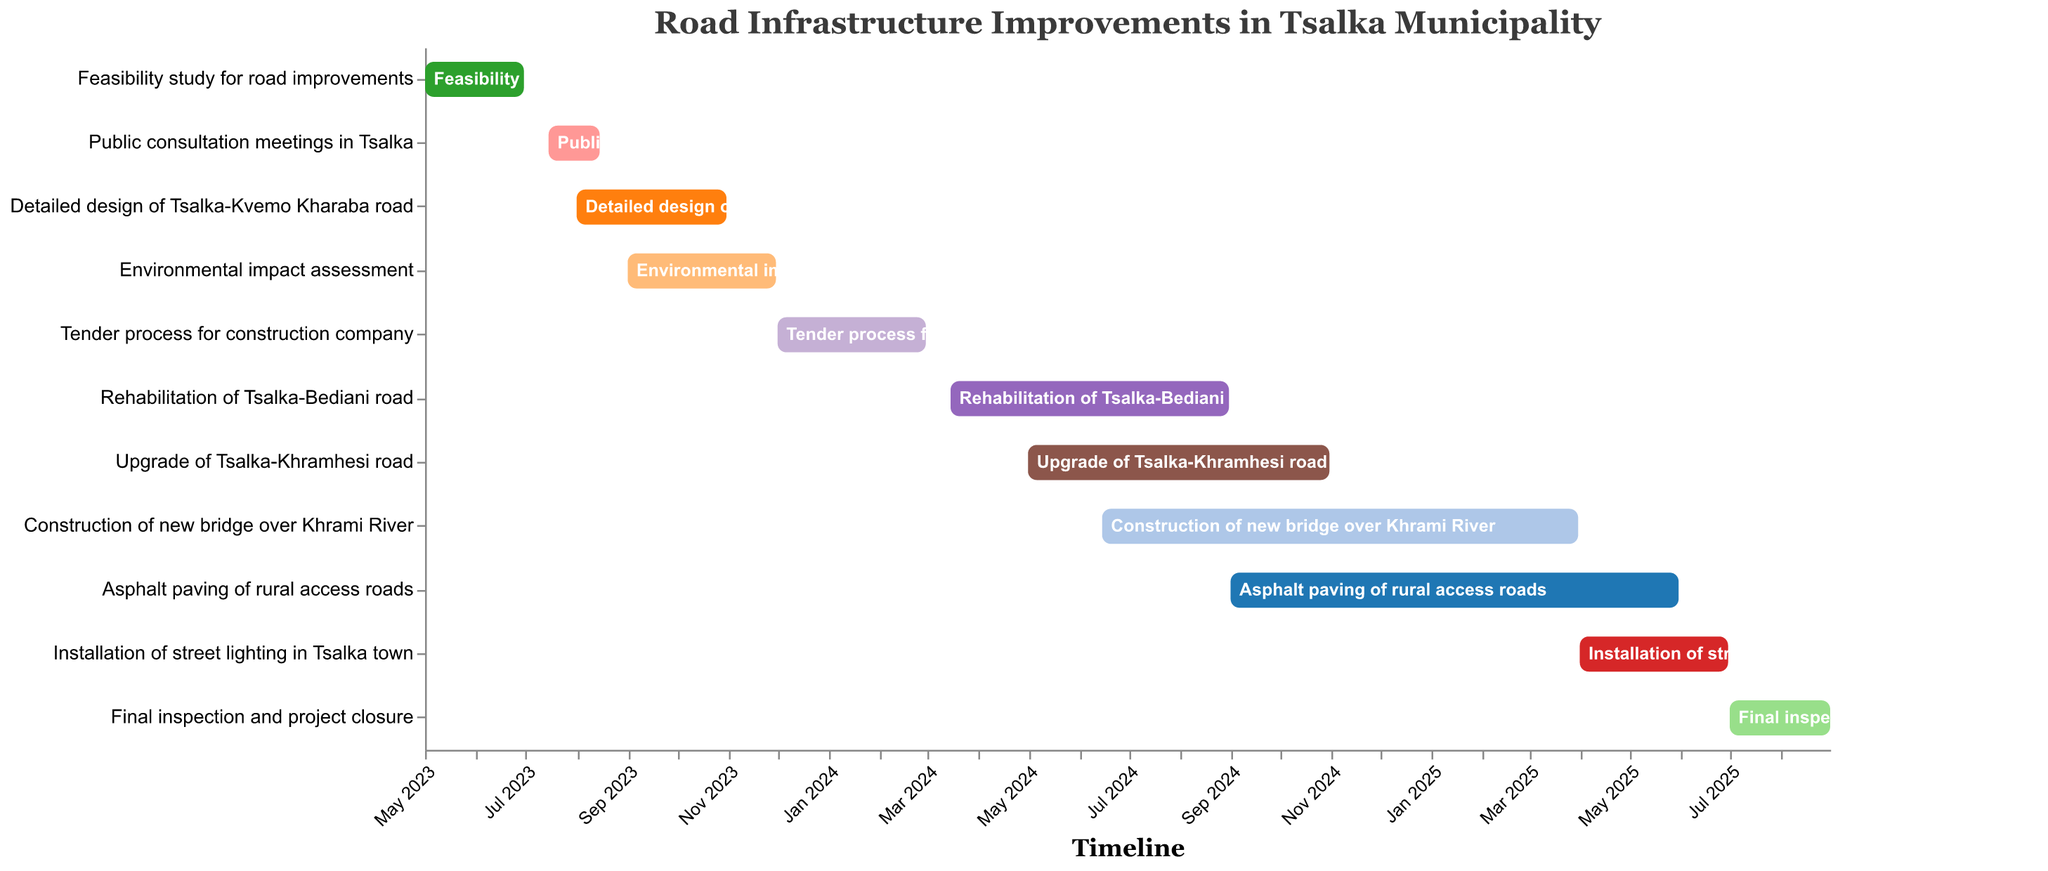When will the feasibility study for road improvements start? The feasibility study for road improvements starts at the "Start Date" of the first task listed in the figure.
Answer: May 1, 2023 How long is the duration of the public consultation meetings in Tsalka? The duration is calculated by finding the difference between the "End Date" and the "Start Date" of the public consultation meetings' task. The task starts on July 15, 2023, and ends on August 15, 2023.
Answer: 1 month Which task has the longest duration? The longest duration is found by comparing the length of time from the start to end date for each task. The "Construction of new bridge over Khrami River" starts on June 15, 2024, and ends on March 31, 2025, which spans over 9.5 months.
Answer: Construction of new bridge over Khrami River When will the final inspection and project closure take place? The "Start Date" and "End Date" for the final inspection and project closure are directly provided in the figure. The task starts on July 1, 2025, and ends on August 31, 2025.
Answer: July 1, 2025 to August 31, 2025 How many tasks will be occurring simultaneously in September 2024? Identify tasks that are ongoing in September 2024. These tasks include "Rehabilitation of Tsalka-Bediani road" (until August 31, 2024), "Upgrade of Tsalka-Khramhesi road" (until October 31, 2024), "Construction of new bridge over Khrami River" (until March 31, 2025), and "Asphalt paving of rural access roads" (starting September 1, 2024).
Answer: 4 tasks Which tasks overlap with the environmental impact assessment? To find overlapping tasks, compare the timeline of the "Environmental impact assessment" (September 1, 2023, to November 30, 2023) with other tasks. The overlapping tasks are "Detailed design of Tsalka-Kvemo Kharaba road" (until October 31, 2023) and "Tender process for construction company" (starting December 1, 2023).
Answer: Detailed design of Tsalka-Kvemo Kharaba road What is the total time span covered by the entire project timeline? The total span is calculated by identifying the "Start Date" of the first task and the "End Date" of the last task. The project starts on May 1, 2023, and ends on August 31, 2025.
Answer: 28 months When does the installation of street lighting in Tsalka town start? The start date of the installation of street lighting in Tsalka town is directly provided in the figure.
Answer: April 1, 2025 What is the sequence of tasks starting from the detailed design of Tsalka-Kvemo Kharaba road? To determine the sequence, list the tasks starting after the detailed design of Tsalka-Kvemo Kharaba road (August 1, 2023, to October 31, 2023). Next tasks are "Environmental impact assessment," followed by "Tender process for construction company," and so on.
Answer: Environmental impact assessment, Tender process for construction company, Rehabilitation of Tsalka-Bediani road, Upgrade of Tsalka-Khramhesi road, Construction of new bridge over Khrami River, Asphalt paving of rural access roads, Installation of street lighting in Tsalka town, Final inspection and project closure When is the asphalt paving of rural access roads scheduled to end? The end date for asphalt paving of rural access roads is directly provided in the figure.
Answer: May 31, 2025 